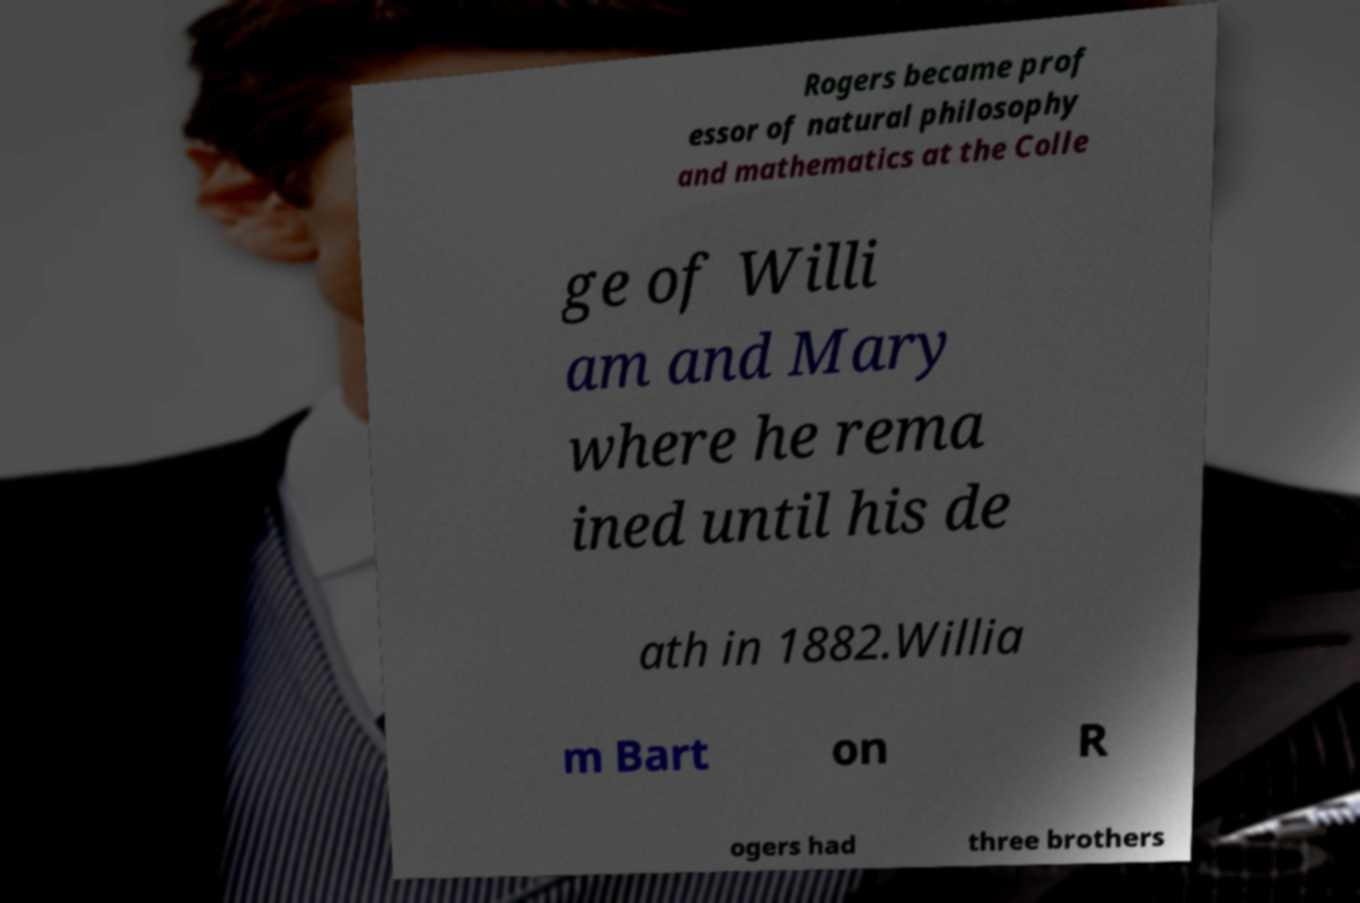I need the written content from this picture converted into text. Can you do that? Rogers became prof essor of natural philosophy and mathematics at the Colle ge of Willi am and Mary where he rema ined until his de ath in 1882.Willia m Bart on R ogers had three brothers 